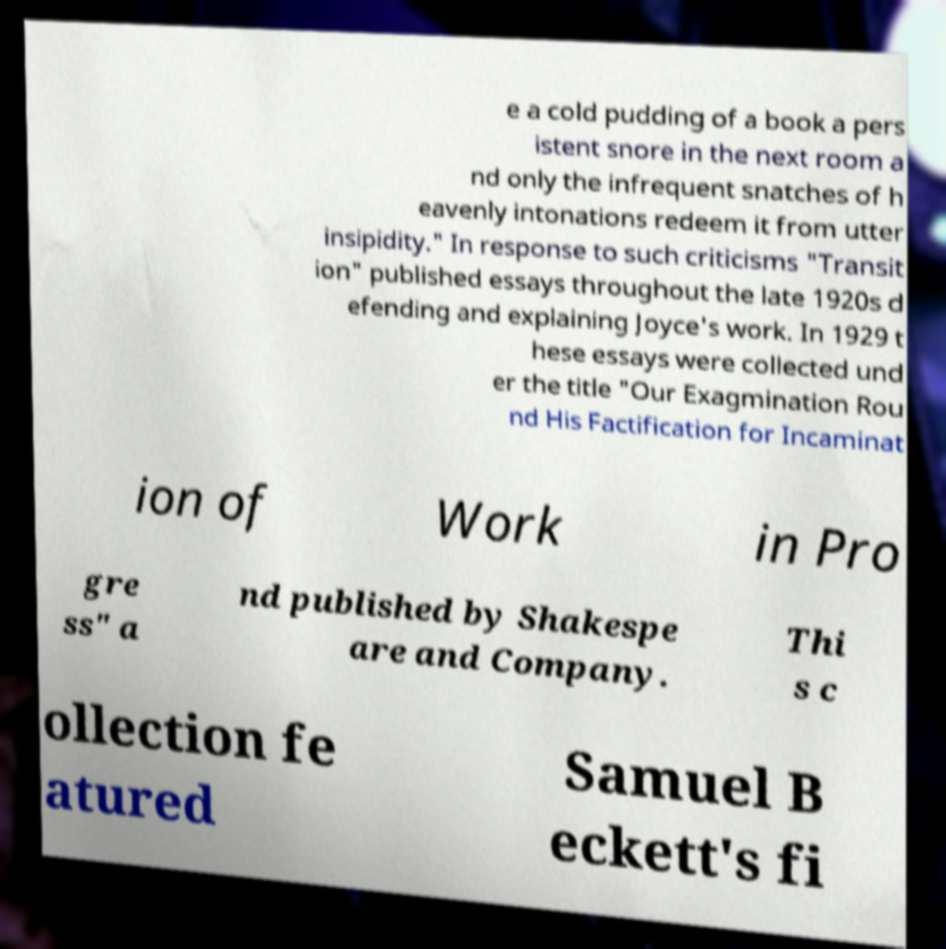There's text embedded in this image that I need extracted. Can you transcribe it verbatim? e a cold pudding of a book a pers istent snore in the next room a nd only the infrequent snatches of h eavenly intonations redeem it from utter insipidity." In response to such criticisms "Transit ion" published essays throughout the late 1920s d efending and explaining Joyce's work. In 1929 t hese essays were collected und er the title "Our Exagmination Rou nd His Factification for Incaminat ion of Work in Pro gre ss" a nd published by Shakespe are and Company. Thi s c ollection fe atured Samuel B eckett's fi 